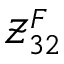Convert formula to latex. <formula><loc_0><loc_0><loc_500><loc_500>\mathcal { Z } _ { 3 2 } ^ { F }</formula> 